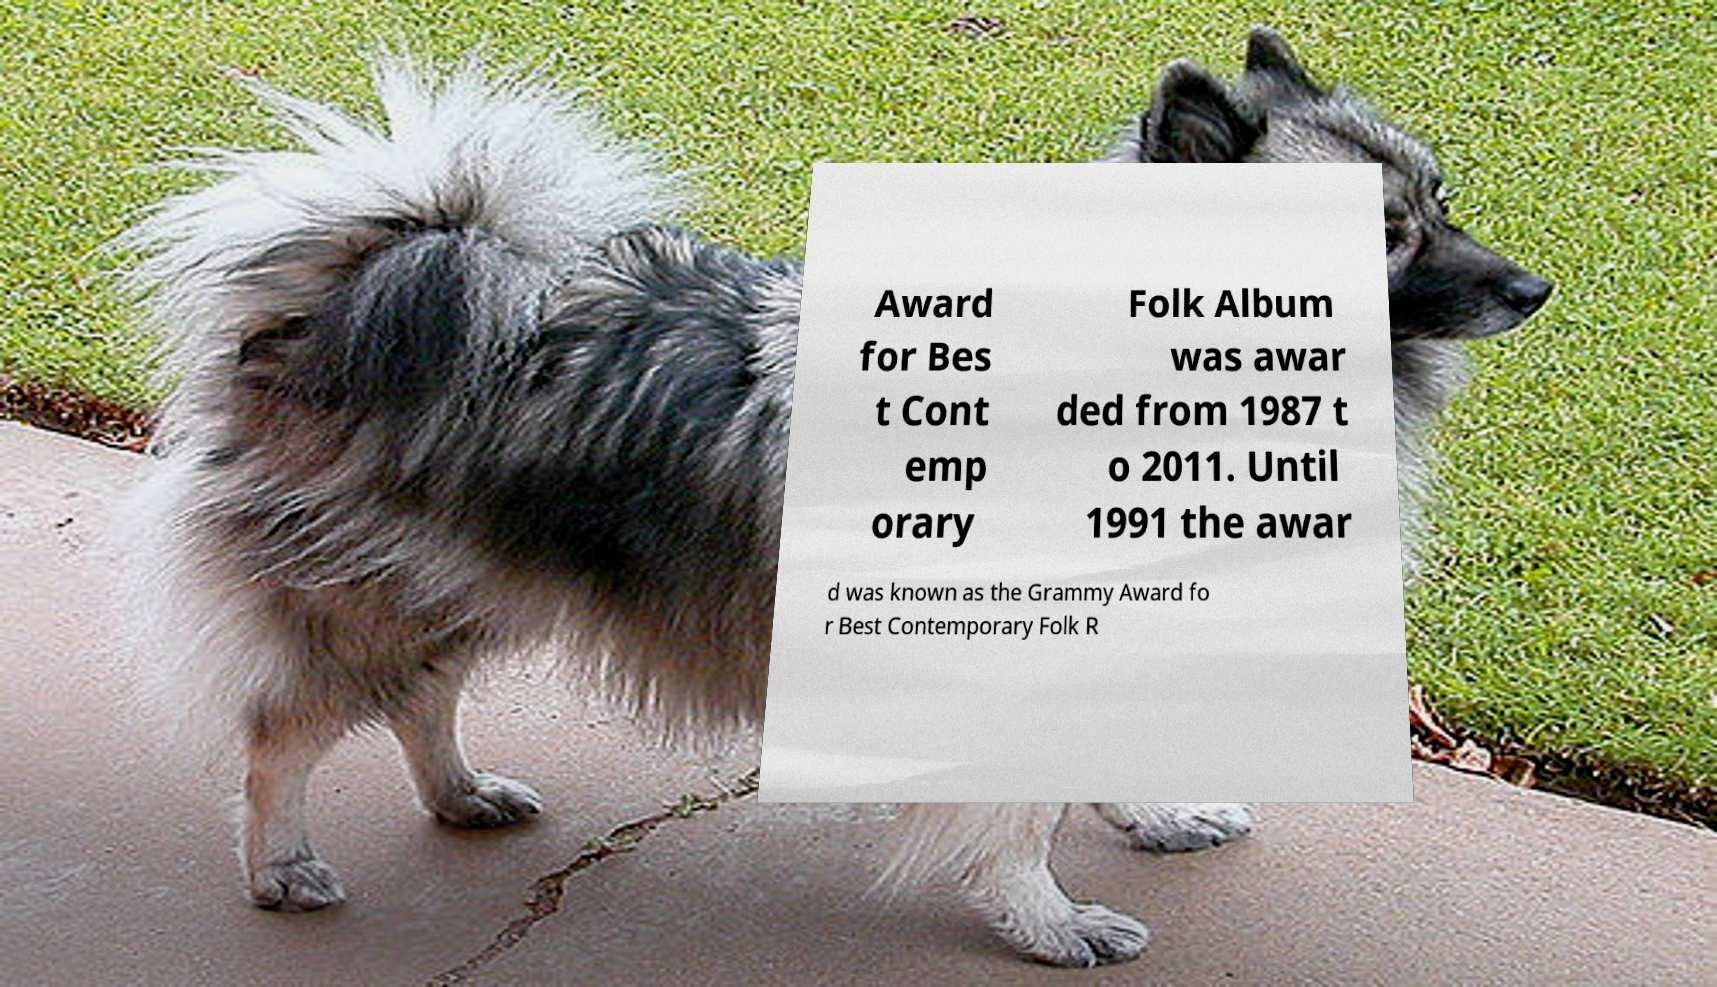Can you accurately transcribe the text from the provided image for me? Award for Bes t Cont emp orary Folk Album was awar ded from 1987 t o 2011. Until 1991 the awar d was known as the Grammy Award fo r Best Contemporary Folk R 